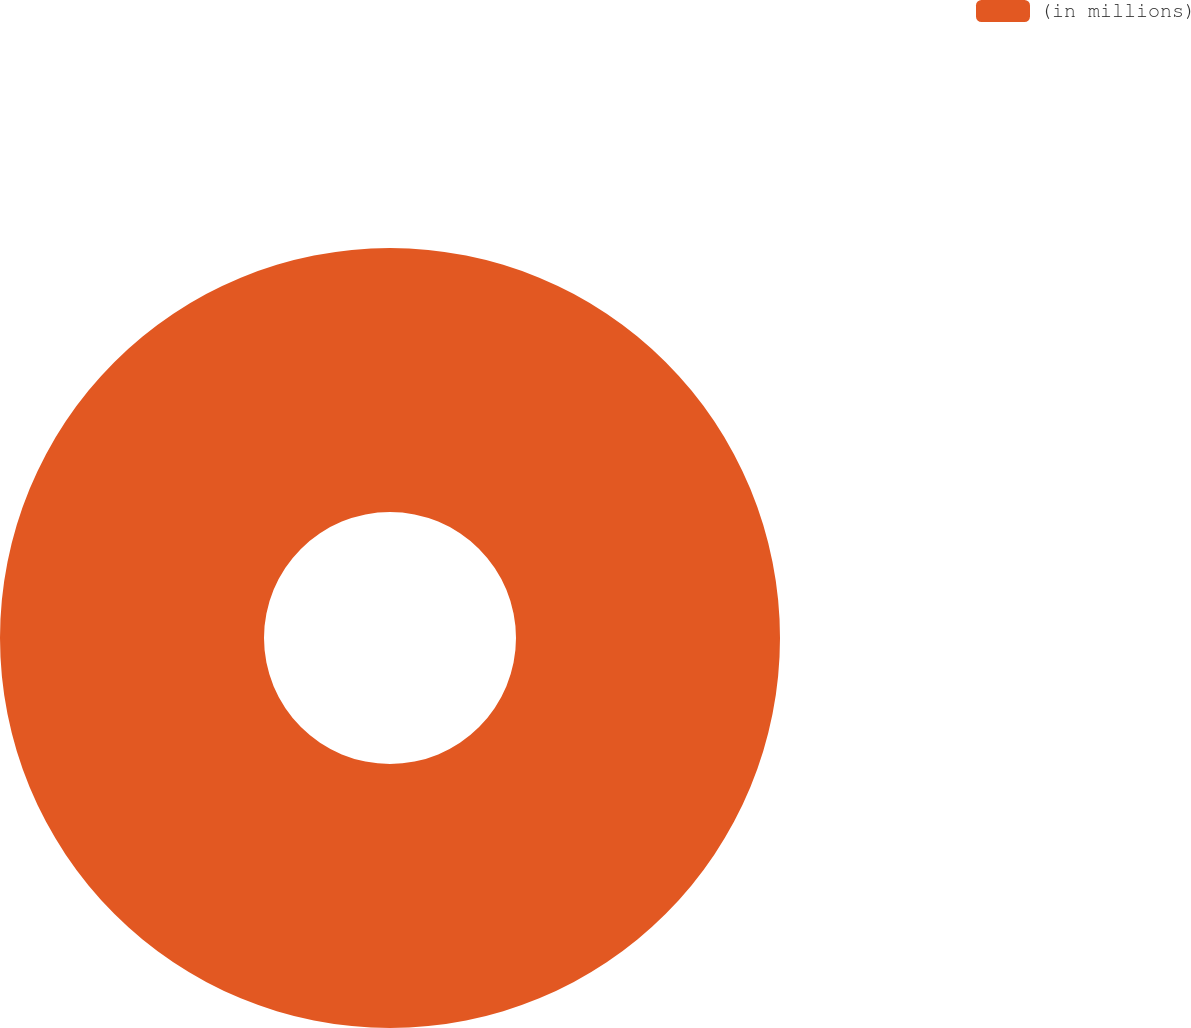<chart> <loc_0><loc_0><loc_500><loc_500><pie_chart><fcel>(in millions)<nl><fcel>100.0%<nl></chart> 